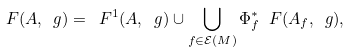Convert formula to latex. <formula><loc_0><loc_0><loc_500><loc_500>\ F ( A , \ g ) = \ F ^ { 1 } ( A , \ g ) \cup \bigcup _ { f \in \mathcal { E } ( M ) } \Phi _ { f } ^ { * } \ F ( A _ { f } , \ g ) ,</formula> 